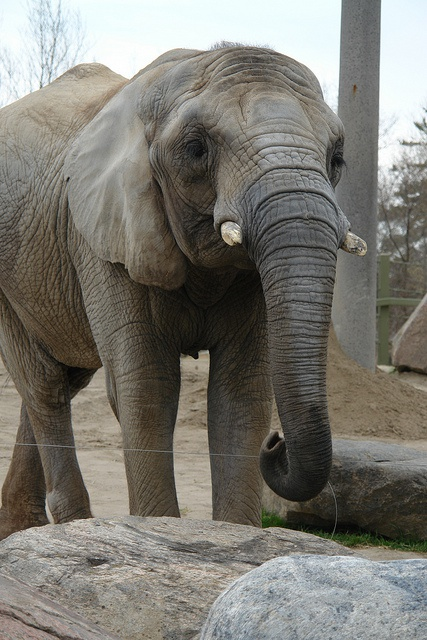Describe the objects in this image and their specific colors. I can see a elephant in white, gray, black, and darkgray tones in this image. 